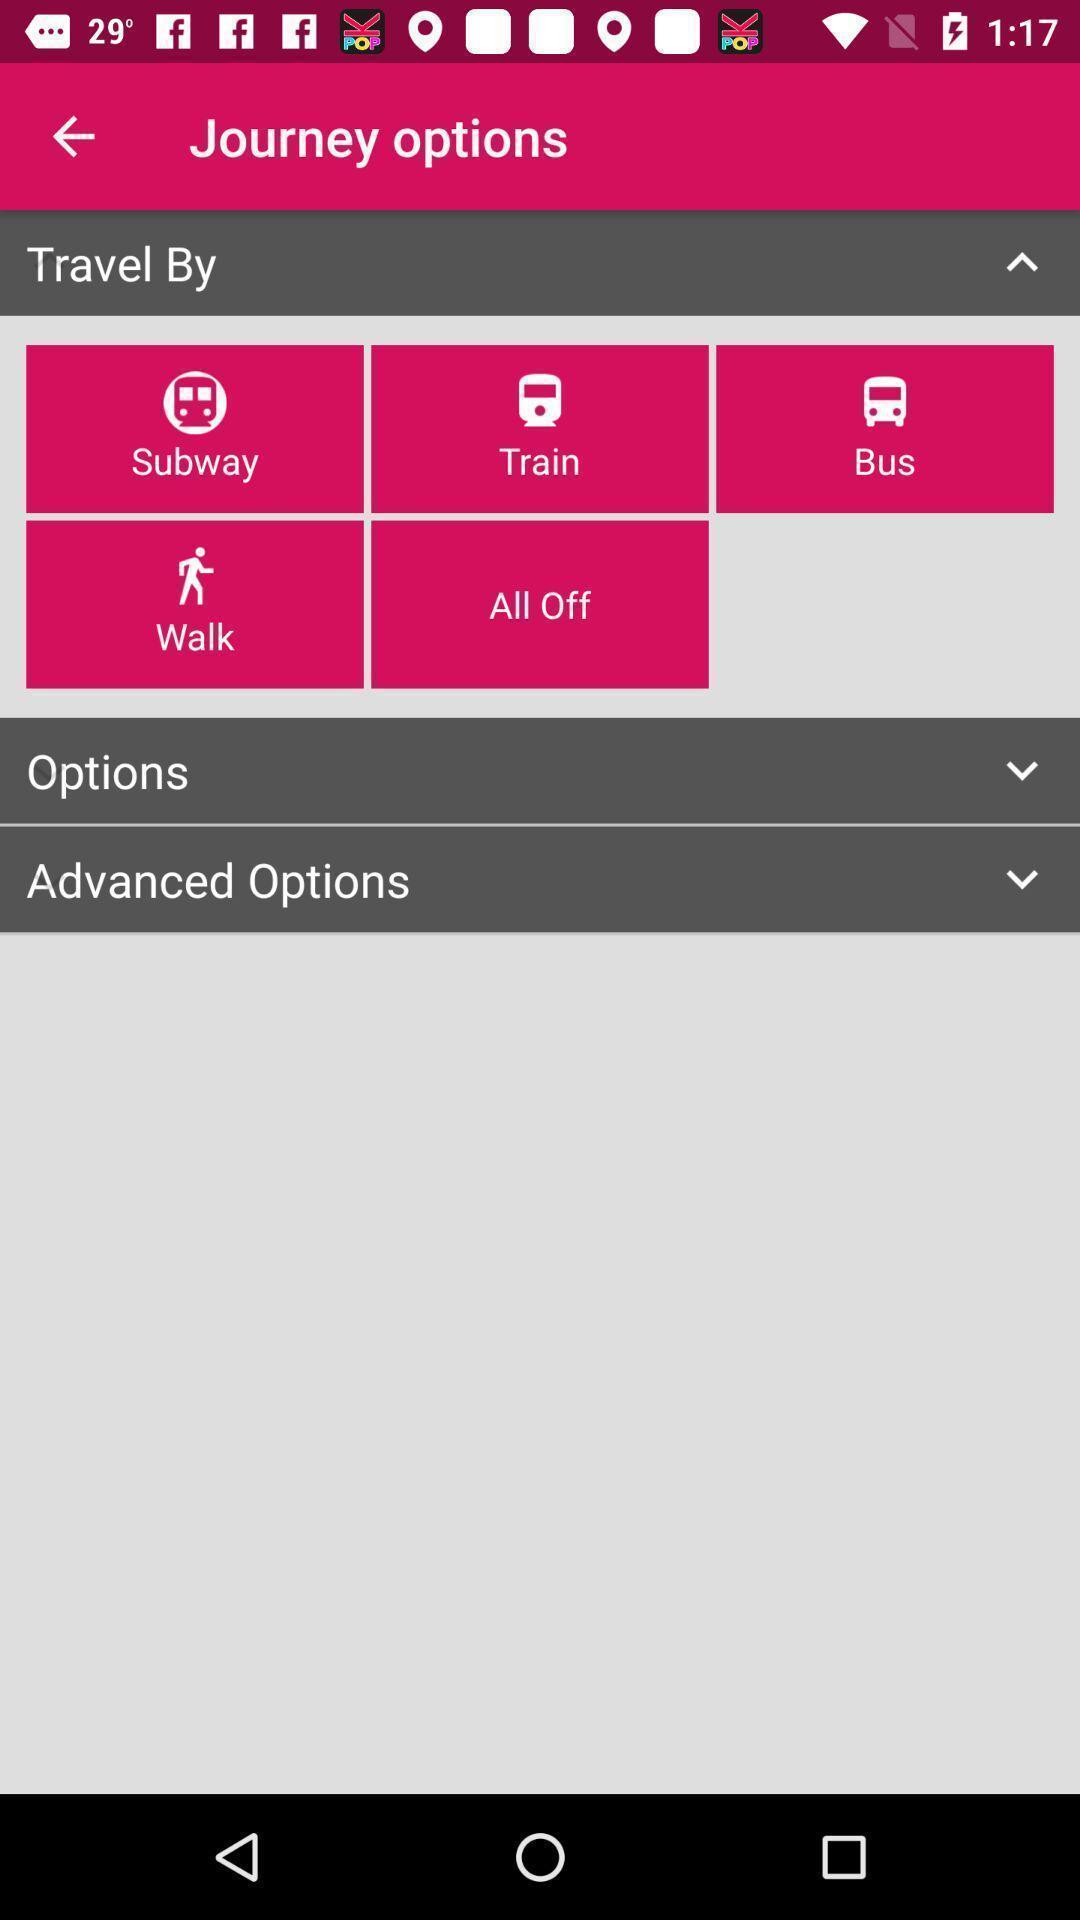Describe the key features of this screenshot. Screen showing journey options of a travel app. 